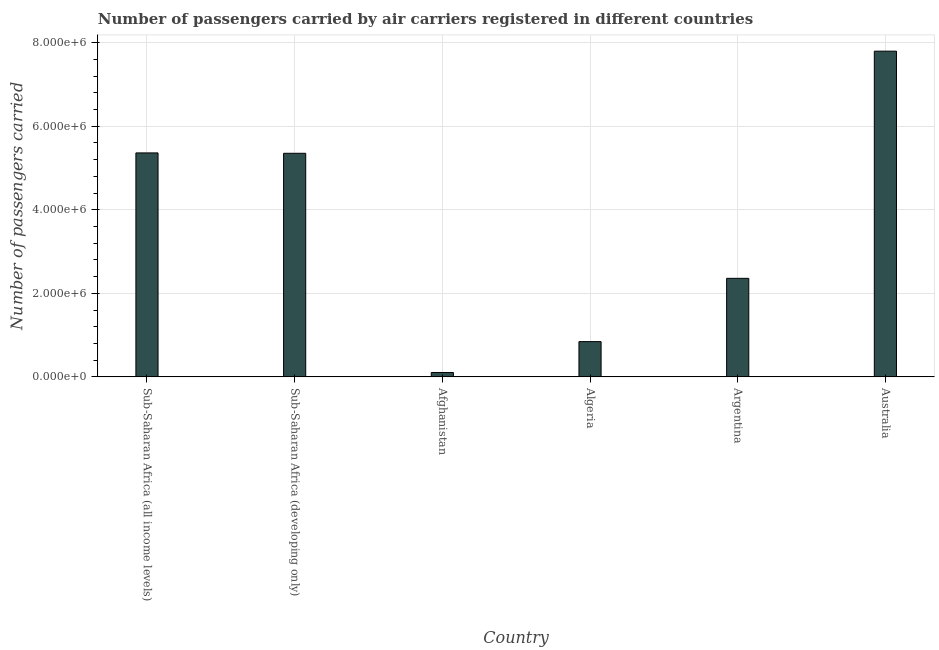What is the title of the graph?
Your response must be concise. Number of passengers carried by air carriers registered in different countries. What is the label or title of the Y-axis?
Ensure brevity in your answer.  Number of passengers carried. What is the number of passengers carried in Australia?
Offer a terse response. 7.80e+06. Across all countries, what is the maximum number of passengers carried?
Offer a very short reply. 7.80e+06. Across all countries, what is the minimum number of passengers carried?
Your answer should be compact. 1.05e+05. In which country was the number of passengers carried minimum?
Make the answer very short. Afghanistan. What is the sum of the number of passengers carried?
Your answer should be very brief. 2.18e+07. What is the difference between the number of passengers carried in Algeria and Australia?
Ensure brevity in your answer.  -6.95e+06. What is the average number of passengers carried per country?
Make the answer very short. 3.64e+06. What is the median number of passengers carried?
Your answer should be very brief. 3.85e+06. In how many countries, is the number of passengers carried greater than 6400000 ?
Offer a very short reply. 1. What is the ratio of the number of passengers carried in Afghanistan to that in Australia?
Give a very brief answer. 0.01. Is the difference between the number of passengers carried in Argentina and Australia greater than the difference between any two countries?
Your answer should be compact. No. What is the difference between the highest and the second highest number of passengers carried?
Provide a succinct answer. 2.44e+06. What is the difference between the highest and the lowest number of passengers carried?
Give a very brief answer. 7.69e+06. In how many countries, is the number of passengers carried greater than the average number of passengers carried taken over all countries?
Your answer should be very brief. 3. How many bars are there?
Provide a short and direct response. 6. Are all the bars in the graph horizontal?
Your answer should be very brief. No. What is the difference between two consecutive major ticks on the Y-axis?
Provide a succinct answer. 2.00e+06. Are the values on the major ticks of Y-axis written in scientific E-notation?
Keep it short and to the point. Yes. What is the Number of passengers carried in Sub-Saharan Africa (all income levels)?
Offer a very short reply. 5.36e+06. What is the Number of passengers carried of Sub-Saharan Africa (developing only)?
Provide a succinct answer. 5.35e+06. What is the Number of passengers carried of Afghanistan?
Offer a very short reply. 1.05e+05. What is the Number of passengers carried in Algeria?
Your answer should be very brief. 8.44e+05. What is the Number of passengers carried of Argentina?
Make the answer very short. 2.36e+06. What is the Number of passengers carried in Australia?
Keep it short and to the point. 7.80e+06. What is the difference between the Number of passengers carried in Sub-Saharan Africa (all income levels) and Sub-Saharan Africa (developing only)?
Make the answer very short. 9000. What is the difference between the Number of passengers carried in Sub-Saharan Africa (all income levels) and Afghanistan?
Provide a succinct answer. 5.26e+06. What is the difference between the Number of passengers carried in Sub-Saharan Africa (all income levels) and Algeria?
Your answer should be compact. 4.52e+06. What is the difference between the Number of passengers carried in Sub-Saharan Africa (all income levels) and Argentina?
Offer a terse response. 3.00e+06. What is the difference between the Number of passengers carried in Sub-Saharan Africa (all income levels) and Australia?
Offer a very short reply. -2.44e+06. What is the difference between the Number of passengers carried in Sub-Saharan Africa (developing only) and Afghanistan?
Offer a very short reply. 5.25e+06. What is the difference between the Number of passengers carried in Sub-Saharan Africa (developing only) and Algeria?
Keep it short and to the point. 4.51e+06. What is the difference between the Number of passengers carried in Sub-Saharan Africa (developing only) and Argentina?
Ensure brevity in your answer.  2.99e+06. What is the difference between the Number of passengers carried in Sub-Saharan Africa (developing only) and Australia?
Offer a terse response. -2.44e+06. What is the difference between the Number of passengers carried in Afghanistan and Algeria?
Provide a succinct answer. -7.39e+05. What is the difference between the Number of passengers carried in Afghanistan and Argentina?
Your answer should be very brief. -2.25e+06. What is the difference between the Number of passengers carried in Afghanistan and Australia?
Make the answer very short. -7.69e+06. What is the difference between the Number of passengers carried in Algeria and Argentina?
Provide a succinct answer. -1.51e+06. What is the difference between the Number of passengers carried in Algeria and Australia?
Make the answer very short. -6.95e+06. What is the difference between the Number of passengers carried in Argentina and Australia?
Offer a terse response. -5.44e+06. What is the ratio of the Number of passengers carried in Sub-Saharan Africa (all income levels) to that in Afghanistan?
Your response must be concise. 51.1. What is the ratio of the Number of passengers carried in Sub-Saharan Africa (all income levels) to that in Algeria?
Provide a succinct answer. 6.35. What is the ratio of the Number of passengers carried in Sub-Saharan Africa (all income levels) to that in Argentina?
Your answer should be very brief. 2.27. What is the ratio of the Number of passengers carried in Sub-Saharan Africa (all income levels) to that in Australia?
Offer a very short reply. 0.69. What is the ratio of the Number of passengers carried in Sub-Saharan Africa (developing only) to that in Afghanistan?
Your response must be concise. 51.01. What is the ratio of the Number of passengers carried in Sub-Saharan Africa (developing only) to that in Algeria?
Your answer should be compact. 6.34. What is the ratio of the Number of passengers carried in Sub-Saharan Africa (developing only) to that in Argentina?
Offer a very short reply. 2.27. What is the ratio of the Number of passengers carried in Sub-Saharan Africa (developing only) to that in Australia?
Provide a short and direct response. 0.69. What is the ratio of the Number of passengers carried in Afghanistan to that in Algeria?
Provide a succinct answer. 0.12. What is the ratio of the Number of passengers carried in Afghanistan to that in Argentina?
Provide a short and direct response. 0.04. What is the ratio of the Number of passengers carried in Afghanistan to that in Australia?
Give a very brief answer. 0.01. What is the ratio of the Number of passengers carried in Algeria to that in Argentina?
Offer a very short reply. 0.36. What is the ratio of the Number of passengers carried in Algeria to that in Australia?
Provide a short and direct response. 0.11. What is the ratio of the Number of passengers carried in Argentina to that in Australia?
Make the answer very short. 0.3. 